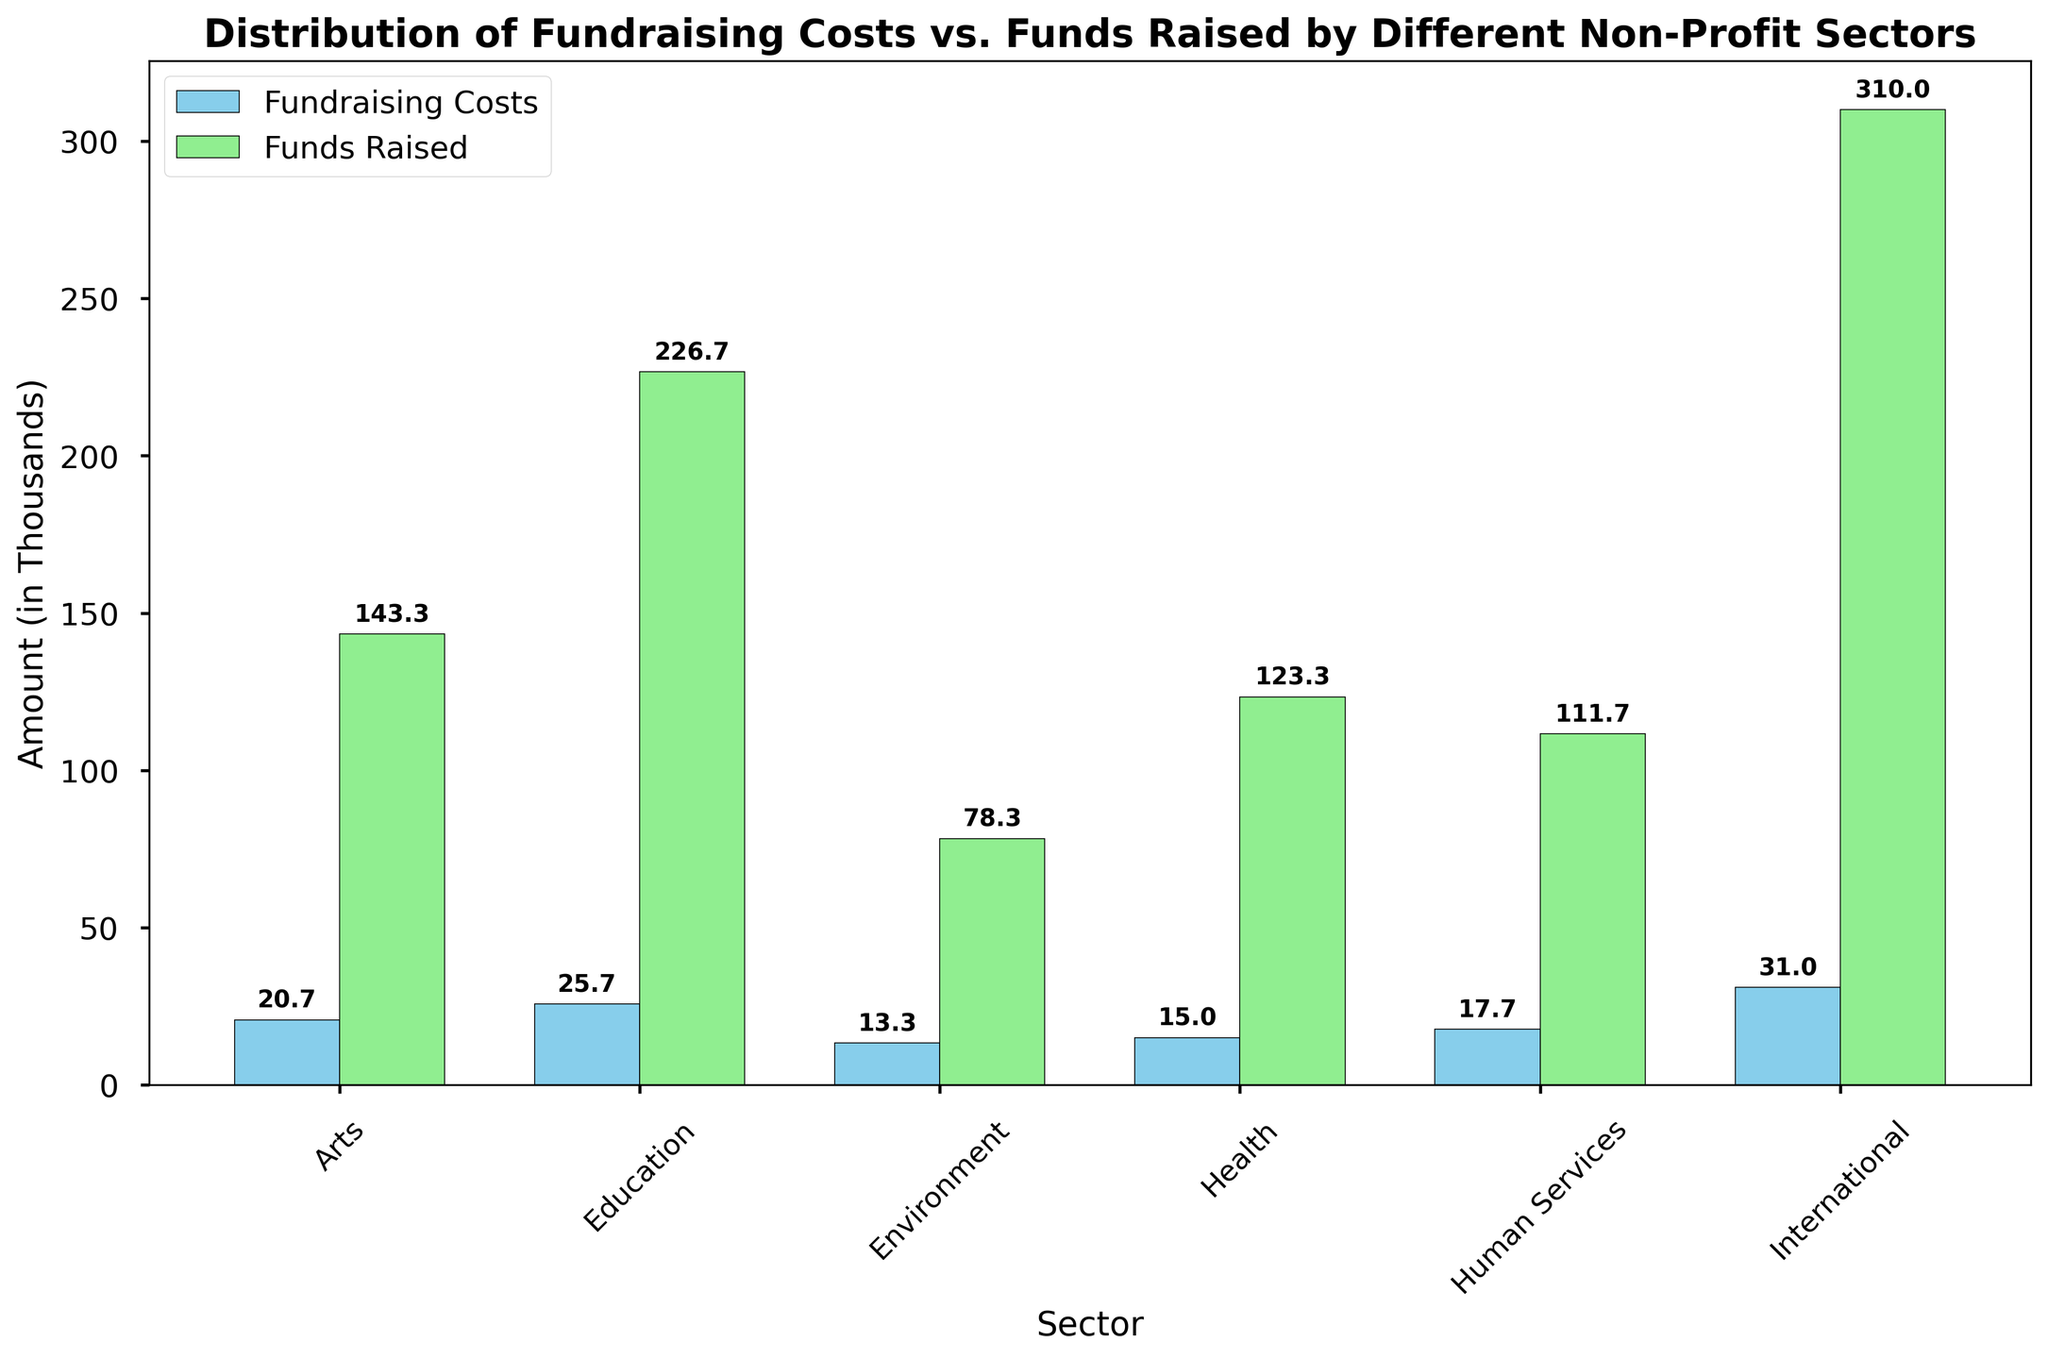what is the range between the highest "Funds Raised" and the highest "Fundraising Costs"? The highest "Funds Raised" is 300 by the "International" sector, and the highest "Fundraising Costs" is 30 by the "International" sector. The range is calculated by subtracting the highest fundraising costs from the highest funds raised: 300 - 30.
Answer: 270 Which sector has the lowest fundraising costs? By observing the heights of the blue bars representing fundraising costs, the "Environment" sector has the lowest average fundraising cost.
Answer: Environment How much more does the "International" sector raise compared to the "Arts" sector? The "International" sector raises 310 on average, and the "Arts" sector raises 143.33 on average. The difference is 310 - 143.33.
Answer: 166.67 Is there any sector where the fundraising costs exceed the funds raised? By comparing the heights of the bars for each sector, there is no sector where the blue bars (fundraising costs) exceed the green bars (funds raised).
Answer: No What is the average of the fundraising costs for the "Health" sector? The average fundraising cost can be calculated by summing up the fundraising costs for the "Health" sector and dividing it by the number of data points. (15 + 20 + 10) / 3 = 45 / 3 = 15.
Answer: 15 Which sector has the lowest difference between funds raised and fundraising costs? The sector with the smallest difference can be derived by visually inspecting the difference in height between the green (funds raised) and blue (fundraising costs) bars. The "Environment" sector shows the smallest difference.
Answer: Environment By how much do fundraising costs in "Education" exceed those in "Arts"? The average fundraising costs for "Education" and "Arts" are 25.67 and 20.67 respectively. The difference is 25.67 - 20.67.
Answer: 5 Which sector has the highest average fundraising costs? By comparing the height of the blue bars, the "International" sector has the highest average fundraising costs at 31.67.
Answer: International 